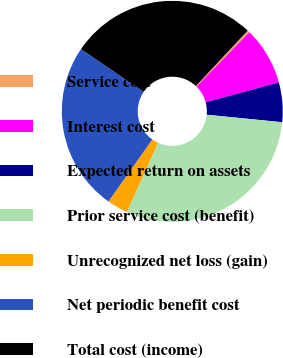<chart> <loc_0><loc_0><loc_500><loc_500><pie_chart><fcel>Service cost<fcel>Interest cost<fcel>Expected return on assets<fcel>Prior service cost (benefit)<fcel>Unrecognized net loss (gain)<fcel>Net periodic benefit cost<fcel>Total cost (income)<nl><fcel>0.34%<fcel>8.5%<fcel>5.78%<fcel>30.16%<fcel>3.06%<fcel>24.72%<fcel>27.44%<nl></chart> 